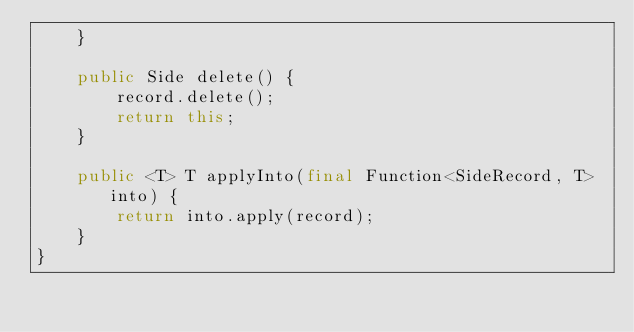<code> <loc_0><loc_0><loc_500><loc_500><_Java_>    }

    public Side delete() {
        record.delete();
        return this;
    }

    public <T> T applyInto(final Function<SideRecord, T> into) {
        return into.apply(record);
    }
}
</code> 